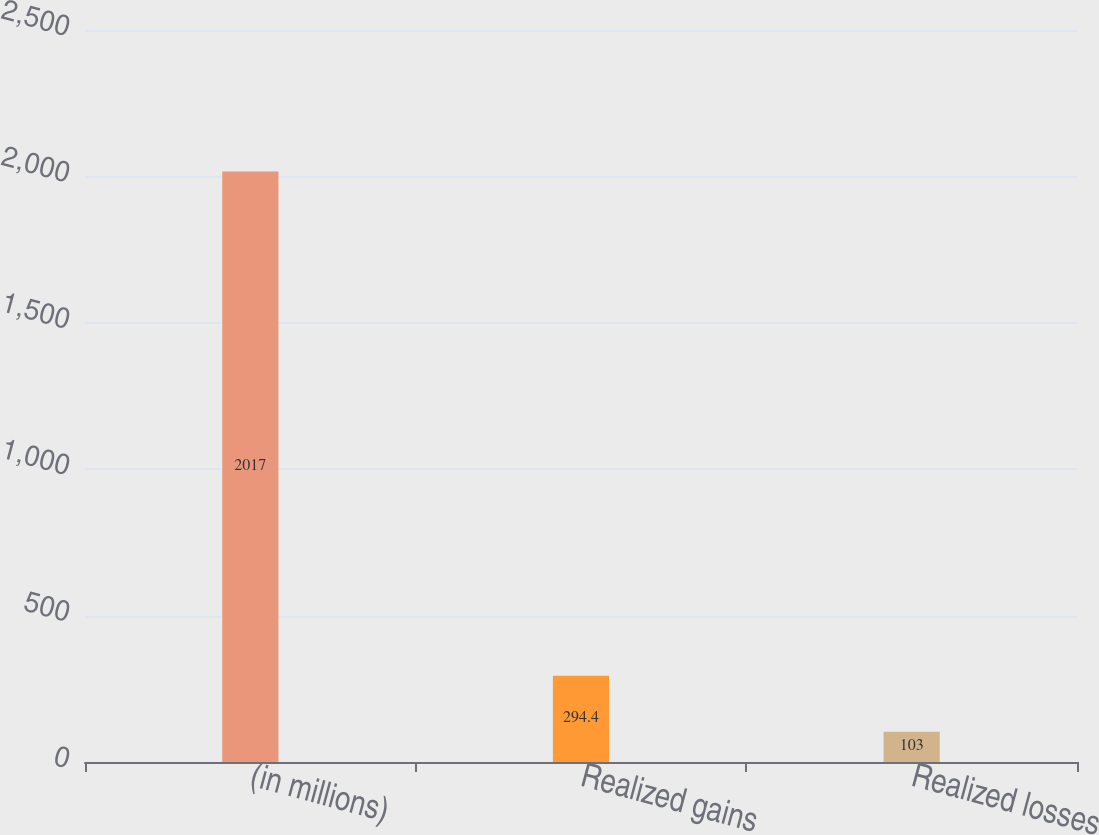<chart> <loc_0><loc_0><loc_500><loc_500><bar_chart><fcel>(in millions)<fcel>Realized gains<fcel>Realized losses<nl><fcel>2017<fcel>294.4<fcel>103<nl></chart> 